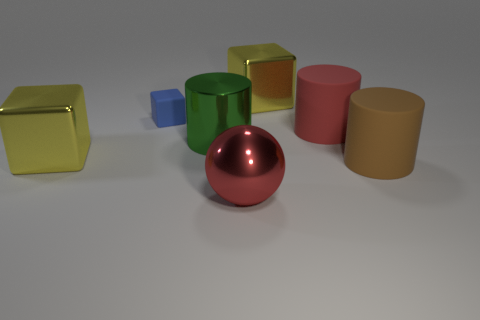Add 1 red rubber cylinders. How many objects exist? 8 Subtract all cubes. How many objects are left? 4 Add 1 red metal balls. How many red metal balls exist? 2 Subtract 0 green balls. How many objects are left? 7 Subtract all big brown rubber balls. Subtract all big rubber cylinders. How many objects are left? 5 Add 6 brown objects. How many brown objects are left? 7 